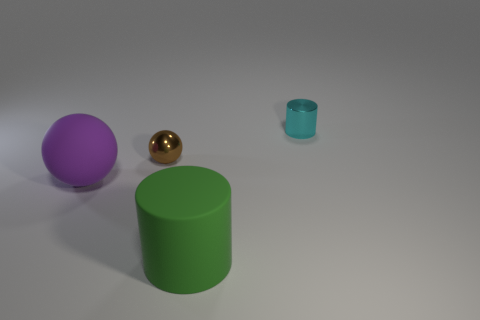Subtract 2 cylinders. How many cylinders are left? 0 Add 3 brown rubber cylinders. How many objects exist? 7 Subtract 0 blue cubes. How many objects are left? 4 Subtract all brown spheres. Subtract all purple cubes. How many spheres are left? 1 Subtract all cyan blocks. How many yellow cylinders are left? 0 Subtract all brown rubber cylinders. Subtract all tiny brown metal objects. How many objects are left? 3 Add 1 purple rubber balls. How many purple rubber balls are left? 2 Add 2 small things. How many small things exist? 4 